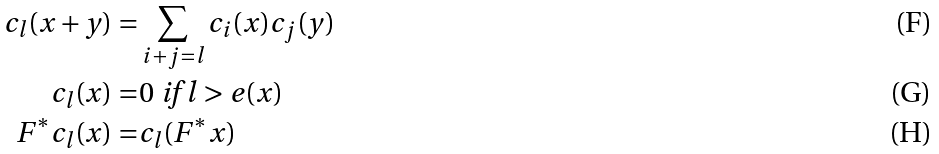<formula> <loc_0><loc_0><loc_500><loc_500>c _ { l } ( x + y ) = & \sum _ { i + j = l } c _ { i } ( x ) c _ { j } ( y ) \\ c _ { l } ( x ) = & 0 \text { if } l > e ( x ) \\ F ^ { * } c _ { l } ( x ) = & c _ { l } ( F ^ { * } x )</formula> 